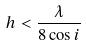<formula> <loc_0><loc_0><loc_500><loc_500>h < \frac { \lambda } { 8 \cos i }</formula> 